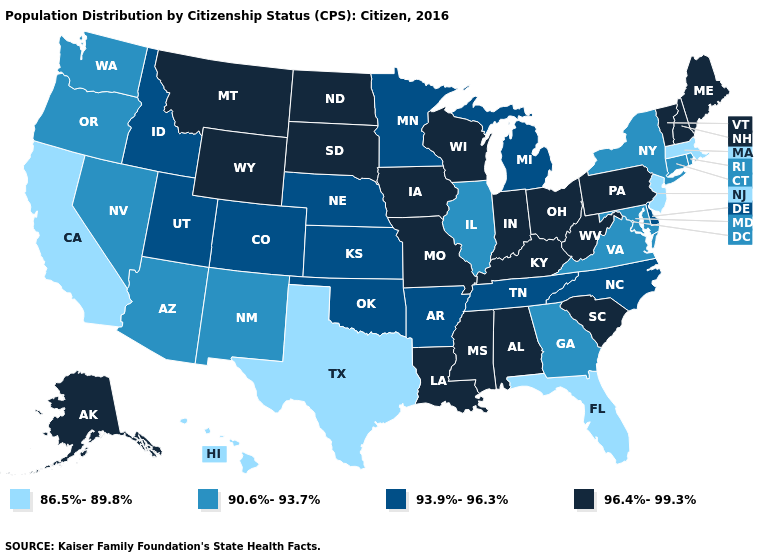What is the value of Kansas?
Answer briefly. 93.9%-96.3%. Does the map have missing data?
Answer briefly. No. How many symbols are there in the legend?
Keep it brief. 4. Name the states that have a value in the range 90.6%-93.7%?
Concise answer only. Arizona, Connecticut, Georgia, Illinois, Maryland, Nevada, New Mexico, New York, Oregon, Rhode Island, Virginia, Washington. Does Indiana have the same value as New Jersey?
Give a very brief answer. No. What is the highest value in the USA?
Be succinct. 96.4%-99.3%. What is the value of Arizona?
Quick response, please. 90.6%-93.7%. What is the value of North Carolina?
Answer briefly. 93.9%-96.3%. What is the value of Georgia?
Be succinct. 90.6%-93.7%. Is the legend a continuous bar?
Quick response, please. No. Does Missouri have a higher value than Ohio?
Keep it brief. No. Which states have the lowest value in the West?
Give a very brief answer. California, Hawaii. What is the value of New York?
Keep it brief. 90.6%-93.7%. Name the states that have a value in the range 90.6%-93.7%?
Short answer required. Arizona, Connecticut, Georgia, Illinois, Maryland, Nevada, New Mexico, New York, Oregon, Rhode Island, Virginia, Washington. What is the highest value in the USA?
Answer briefly. 96.4%-99.3%. 